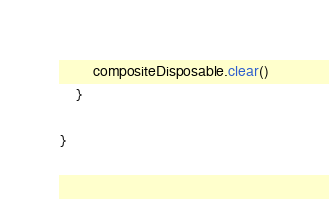<code> <loc_0><loc_0><loc_500><loc_500><_Kotlin_>        compositeDisposable.clear()
    }

}</code> 